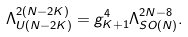<formula> <loc_0><loc_0><loc_500><loc_500>\Lambda _ { U ( N - 2 K ) } ^ { 2 ( N - 2 K ) } = g _ { K + 1 } ^ { 4 } \Lambda _ { S O ( N ) } ^ { 2 N - 8 } .</formula> 